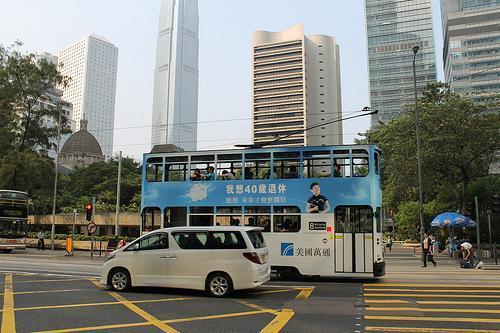How many vehicles are in the picture?
Give a very brief answer. 3. How many tall modern buildings are featured in the photo?
Give a very brief answer. 6. 